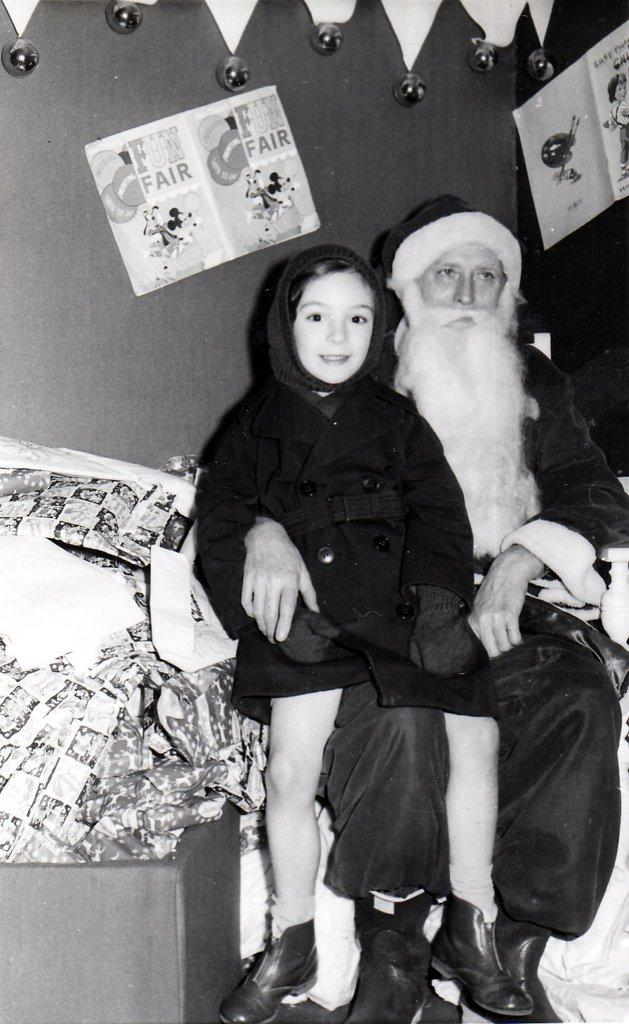What is the color scheme of the image? The image is black and white. How many people are present in the image? There are two persons in the image. What can be seen on the walls in the image? There are posters in the image. What else is visible in the image besides the people and posters? There are objects in the image. What is visible in the background of the image? There is a wall in the background of the image. What type of plantation can be seen in the image? There is no plantation present in the image; it is a black and white image featuring two persons, posters, and objects. What role does the parent play in the image? There is no mention of a parent or any parent-child relationship in the image. 